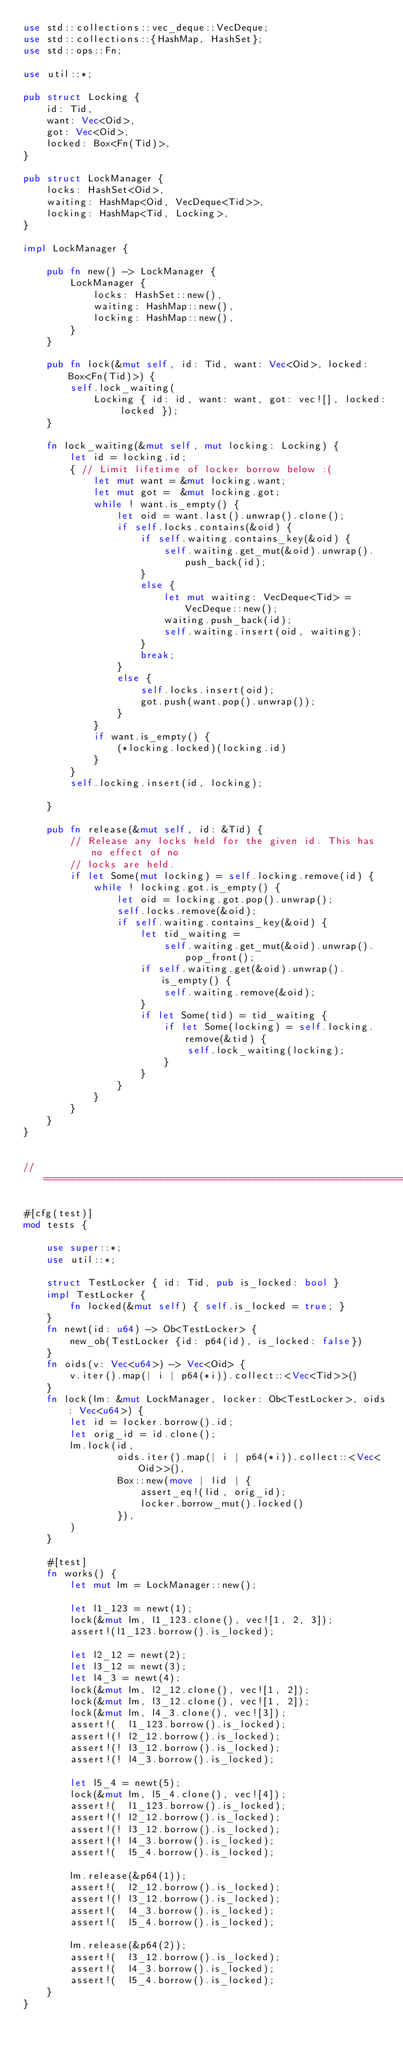Convert code to text. <code><loc_0><loc_0><loc_500><loc_500><_Rust_>use std::collections::vec_deque::VecDeque;
use std::collections::{HashMap, HashSet};
use std::ops::Fn;

use util::*;

pub struct Locking {
    id: Tid,
    want: Vec<Oid>,
    got: Vec<Oid>,
    locked: Box<Fn(Tid)>,
}
    
pub struct LockManager {
    locks: HashSet<Oid>,
    waiting: HashMap<Oid, VecDeque<Tid>>,
    locking: HashMap<Tid, Locking>,
}

impl LockManager {

    pub fn new() -> LockManager {
        LockManager {
            locks: HashSet::new(),
            waiting: HashMap::new(),
            locking: HashMap::new(),
        }
    }

    pub fn lock(&mut self, id: Tid, want: Vec<Oid>, locked: Box<Fn(Tid)>) {
        self.lock_waiting(
            Locking { id: id, want: want, got: vec![], locked: locked });
    }

    fn lock_waiting(&mut self, mut locking: Locking) {
        let id = locking.id;
        { // Limit lifetime of locker borrow below :(
            let mut want = &mut locking.want;
            let mut got =  &mut locking.got;
            while ! want.is_empty() {
                let oid = want.last().unwrap().clone();
                if self.locks.contains(&oid) {
                    if self.waiting.contains_key(&oid) {
                        self.waiting.get_mut(&oid).unwrap().push_back(id);
                    }
                    else {
                        let mut waiting: VecDeque<Tid> = VecDeque::new();
                        waiting.push_back(id);
                        self.waiting.insert(oid, waiting);
                    }
                    break;
                }
                else {
                    self.locks.insert(oid);
                    got.push(want.pop().unwrap());
                }
            }
            if want.is_empty() {
                (*locking.locked)(locking.id)
            }
        }
        self.locking.insert(id, locking);

    }

    pub fn release(&mut self, id: &Tid) {
        // Release any locks held for the given id. This has no effect of no
        // locks are held.
        if let Some(mut locking) = self.locking.remove(id) {
            while ! locking.got.is_empty() {
                let oid = locking.got.pop().unwrap();
                self.locks.remove(&oid);
                if self.waiting.contains_key(&oid) {
                    let tid_waiting =
                        self.waiting.get_mut(&oid).unwrap().pop_front();
                    if self.waiting.get(&oid).unwrap().is_empty() {
                        self.waiting.remove(&oid);
                    }
                    if let Some(tid) = tid_waiting {
                        if let Some(locking) = self.locking.remove(&tid) {
                            self.lock_waiting(locking);
                        }
                    }
                }
            }
        }
    }
}


// ======================================================================

#[cfg(test)]
mod tests {

    use super::*;
    use util::*;

    struct TestLocker { id: Tid, pub is_locked: bool }
    impl TestLocker {
        fn locked(&mut self) { self.is_locked = true; }
    }
    fn newt(id: u64) -> Ob<TestLocker> {
        new_ob(TestLocker {id: p64(id), is_locked: false})
    }
    fn oids(v: Vec<u64>) -> Vec<Oid> {
        v.iter().map(| i | p64(*i)).collect::<Vec<Tid>>()
    }
    fn lock(lm: &mut LockManager, locker: Ob<TestLocker>, oids: Vec<u64>) {
        let id = locker.borrow().id;
        let orig_id = id.clone();
        lm.lock(id,
                oids.iter().map(| i | p64(*i)).collect::<Vec<Oid>>(),
                Box::new(move | lid | {
                    assert_eq!(lid, orig_id);
                    locker.borrow_mut().locked()
                }),
        )
    }
    
    #[test]
    fn works() {
        let mut lm = LockManager::new();
        
        let l1_123 = newt(1);
        lock(&mut lm, l1_123.clone(), vec![1, 2, 3]);
        assert!(l1_123.borrow().is_locked);

        let l2_12 = newt(2);
        let l3_12 = newt(3);
        let l4_3 = newt(4);
        lock(&mut lm, l2_12.clone(), vec![1, 2]);
        lock(&mut lm, l3_12.clone(), vec![1, 2]);
        lock(&mut lm, l4_3.clone(), vec![3]);
        assert!(  l1_123.borrow().is_locked);
        assert!(! l2_12.borrow().is_locked);
        assert!(! l3_12.borrow().is_locked);
        assert!(! l4_3.borrow().is_locked);

        let l5_4 = newt(5);
        lock(&mut lm, l5_4.clone(), vec![4]);
        assert!(  l1_123.borrow().is_locked);
        assert!(! l2_12.borrow().is_locked);
        assert!(! l3_12.borrow().is_locked);
        assert!(! l4_3.borrow().is_locked);
        assert!(  l5_4.borrow().is_locked);

        lm.release(&p64(1));
        assert!(  l2_12.borrow().is_locked);
        assert!(! l3_12.borrow().is_locked);
        assert!(  l4_3.borrow().is_locked);
        assert!(  l5_4.borrow().is_locked);

        lm.release(&p64(2));
        assert!(  l3_12.borrow().is_locked);
        assert!(  l4_3.borrow().is_locked);
        assert!(  l5_4.borrow().is_locked);
    }
}
</code> 